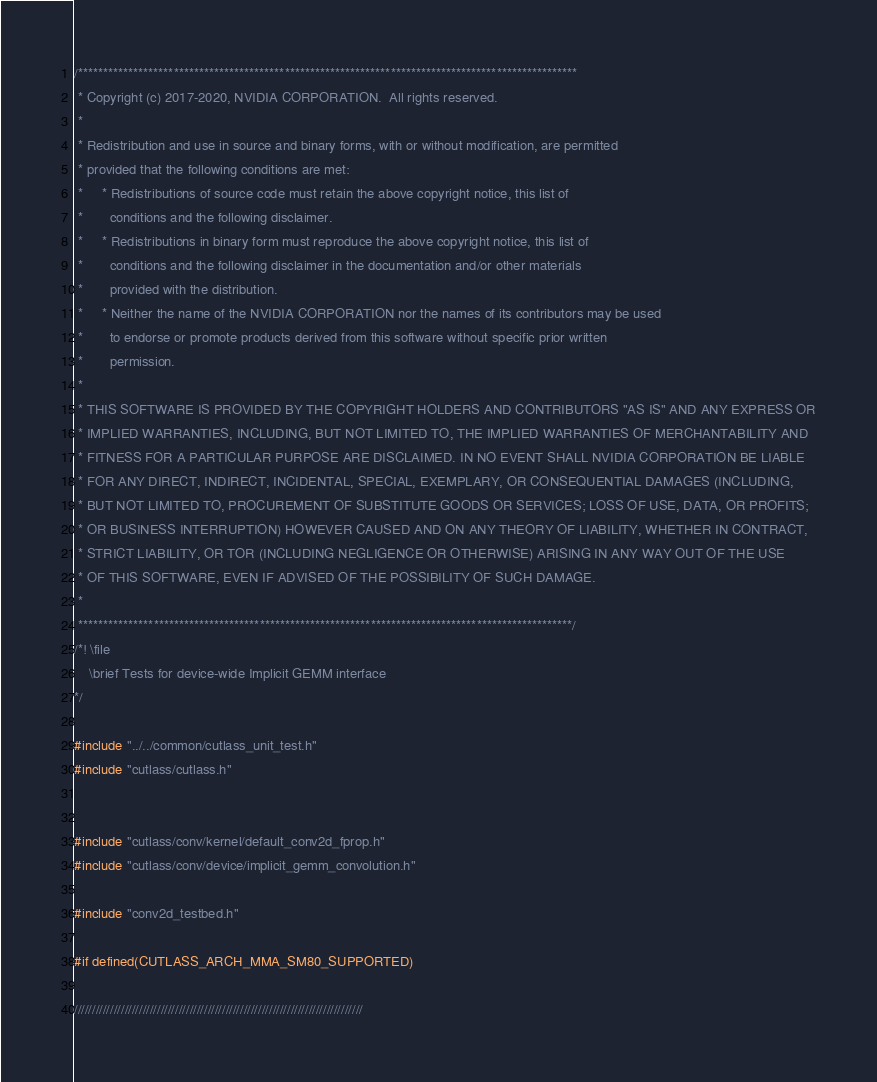Convert code to text. <code><loc_0><loc_0><loc_500><loc_500><_Cuda_>/***************************************************************************************************
 * Copyright (c) 2017-2020, NVIDIA CORPORATION.  All rights reserved.
 *
 * Redistribution and use in source and binary forms, with or without modification, are permitted
 * provided that the following conditions are met:
 *     * Redistributions of source code must retain the above copyright notice, this list of
 *       conditions and the following disclaimer.
 *     * Redistributions in binary form must reproduce the above copyright notice, this list of
 *       conditions and the following disclaimer in the documentation and/or other materials
 *       provided with the distribution.
 *     * Neither the name of the NVIDIA CORPORATION nor the names of its contributors may be used
 *       to endorse or promote products derived from this software without specific prior written
 *       permission.
 *
 * THIS SOFTWARE IS PROVIDED BY THE COPYRIGHT HOLDERS AND CONTRIBUTORS "AS IS" AND ANY EXPRESS OR
 * IMPLIED WARRANTIES, INCLUDING, BUT NOT LIMITED TO, THE IMPLIED WARRANTIES OF MERCHANTABILITY AND
 * FITNESS FOR A PARTICULAR PURPOSE ARE DISCLAIMED. IN NO EVENT SHALL NVIDIA CORPORATION BE LIABLE
 * FOR ANY DIRECT, INDIRECT, INCIDENTAL, SPECIAL, EXEMPLARY, OR CONSEQUENTIAL DAMAGES (INCLUDING,
 * BUT NOT LIMITED TO, PROCUREMENT OF SUBSTITUTE GOODS OR SERVICES; LOSS OF USE, DATA, OR PROFITS;
 * OR BUSINESS INTERRUPTION) HOWEVER CAUSED AND ON ANY THEORY OF LIABILITY, WHETHER IN CONTRACT,
 * STRICT LIABILITY, OR TOR (INCLUDING NEGLIGENCE OR OTHERWISE) ARISING IN ANY WAY OUT OF THE USE
 * OF THIS SOFTWARE, EVEN IF ADVISED OF THE POSSIBILITY OF SUCH DAMAGE.
 *
 **************************************************************************************************/
/*! \file
    \brief Tests for device-wide Implicit GEMM interface
*/

#include "../../common/cutlass_unit_test.h"
#include "cutlass/cutlass.h"


#include "cutlass/conv/kernel/default_conv2d_fprop.h"
#include "cutlass/conv/device/implicit_gemm_convolution.h"

#include "conv2d_testbed.h"

#if defined(CUTLASS_ARCH_MMA_SM80_SUPPORTED)

////////////////////////////////////////////////////////////////////////////////</code> 